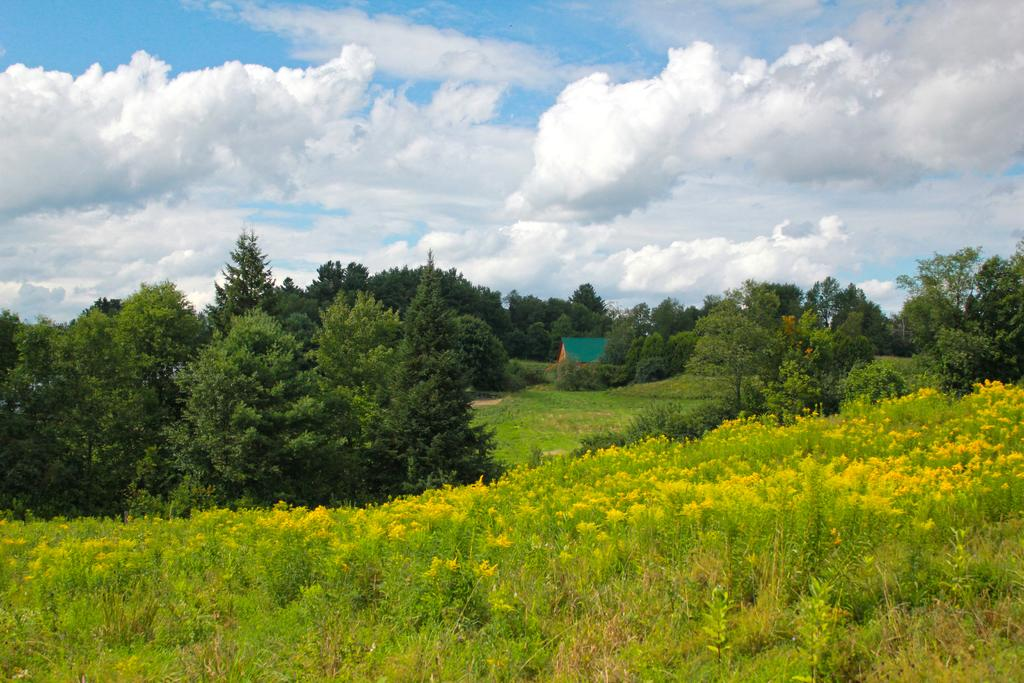What type of ground covering can be seen in the image? The ground in the image is covered with grass. What other natural elements are present in the image? Plants and trees are visible in the image. What is the condition of the sky in the image? The sky is covered with clouds in the image. What type of silver object can be seen in the image? There is no silver object present in the image. What is the position of the chin in the image? There are no people or faces present in the image, so there is no chin to reference. 